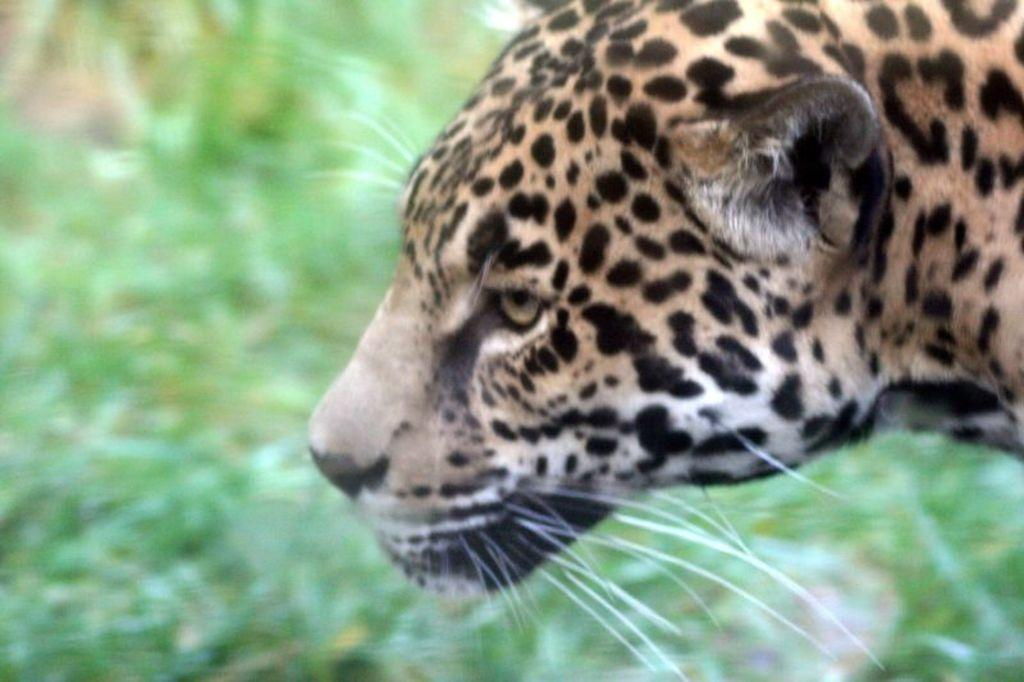What type of animal is in the image? The specific type of animal is not mentioned, but there is an animal present in the image. Where is the animal located in the image? The animal is on the right side of the image. What color is the background of the image? The background of the image is green in color. What type of pie is the animal holding in the image? There is no pie present in the image, and the animal is not holding anything. 